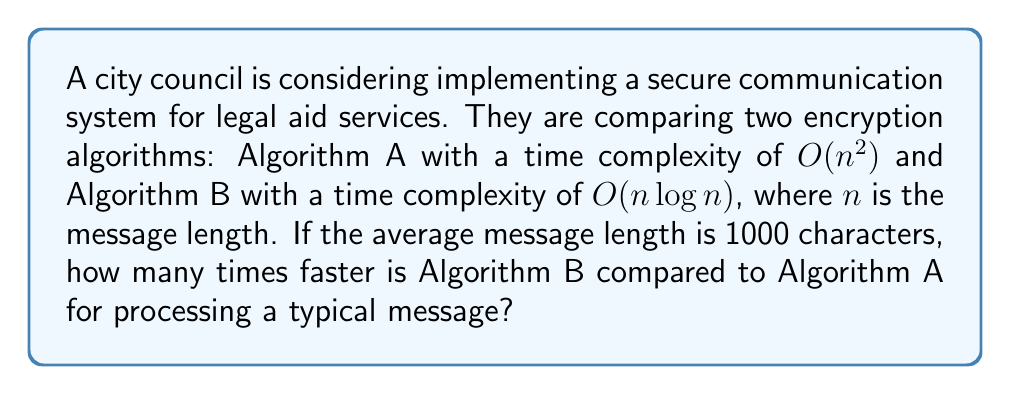Solve this math problem. To compare the speed of the two algorithms, we need to analyze their time complexities:

1. Algorithm A: $O(n^2)$
2. Algorithm B: $O(n \log n)$

For $n = 1000$:

1. Algorithm A: $O(1000^2) = O(1,000,000)$
2. Algorithm B: $O(1000 \log 1000) = O(1000 \times 10) = O(10,000)$

To find how many times faster Algorithm B is, we divide the time complexity of Algorithm A by that of Algorithm B:

$$\frac{O(1,000,000)}{O(10,000)} = 100$$

Therefore, for a message length of 1000 characters, Algorithm B is approximately 100 times faster than Algorithm A.

Note: This comparison is based on the asymptotic behavior and provides an estimate of the relative performance. The actual speed difference may vary in practice due to implementation details and constant factors.
Answer: 100 times faster 